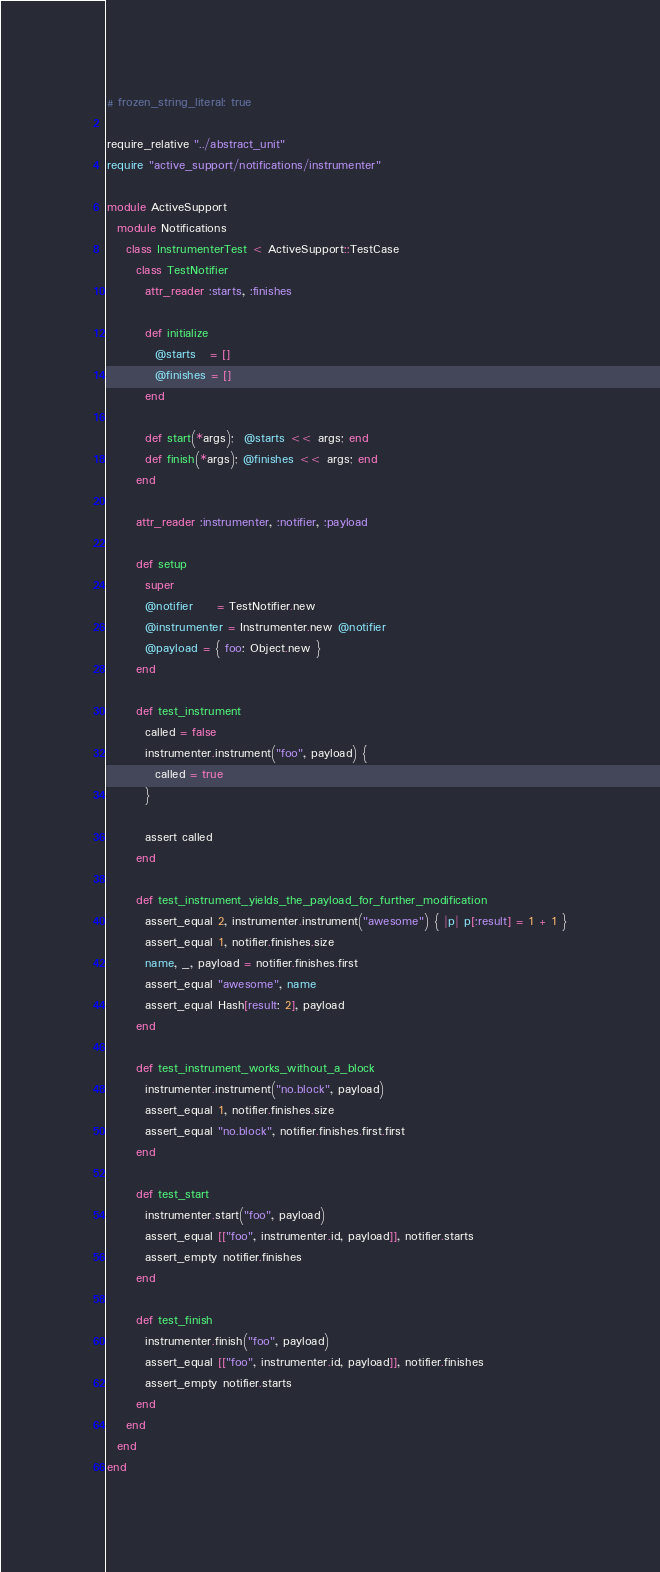<code> <loc_0><loc_0><loc_500><loc_500><_Ruby_># frozen_string_literal: true

require_relative "../abstract_unit"
require "active_support/notifications/instrumenter"

module ActiveSupport
  module Notifications
    class InstrumenterTest < ActiveSupport::TestCase
      class TestNotifier
        attr_reader :starts, :finishes

        def initialize
          @starts   = []
          @finishes = []
        end

        def start(*args);  @starts << args; end
        def finish(*args); @finishes << args; end
      end

      attr_reader :instrumenter, :notifier, :payload

      def setup
        super
        @notifier     = TestNotifier.new
        @instrumenter = Instrumenter.new @notifier
        @payload = { foo: Object.new }
      end

      def test_instrument
        called = false
        instrumenter.instrument("foo", payload) {
          called = true
        }

        assert called
      end

      def test_instrument_yields_the_payload_for_further_modification
        assert_equal 2, instrumenter.instrument("awesome") { |p| p[:result] = 1 + 1 }
        assert_equal 1, notifier.finishes.size
        name, _, payload = notifier.finishes.first
        assert_equal "awesome", name
        assert_equal Hash[result: 2], payload
      end

      def test_instrument_works_without_a_block
        instrumenter.instrument("no.block", payload)
        assert_equal 1, notifier.finishes.size
        assert_equal "no.block", notifier.finishes.first.first
      end

      def test_start
        instrumenter.start("foo", payload)
        assert_equal [["foo", instrumenter.id, payload]], notifier.starts
        assert_empty notifier.finishes
      end

      def test_finish
        instrumenter.finish("foo", payload)
        assert_equal [["foo", instrumenter.id, payload]], notifier.finishes
        assert_empty notifier.starts
      end
    end
  end
end
</code> 